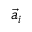<formula> <loc_0><loc_0><loc_500><loc_500>\vec { a } _ { i }</formula> 